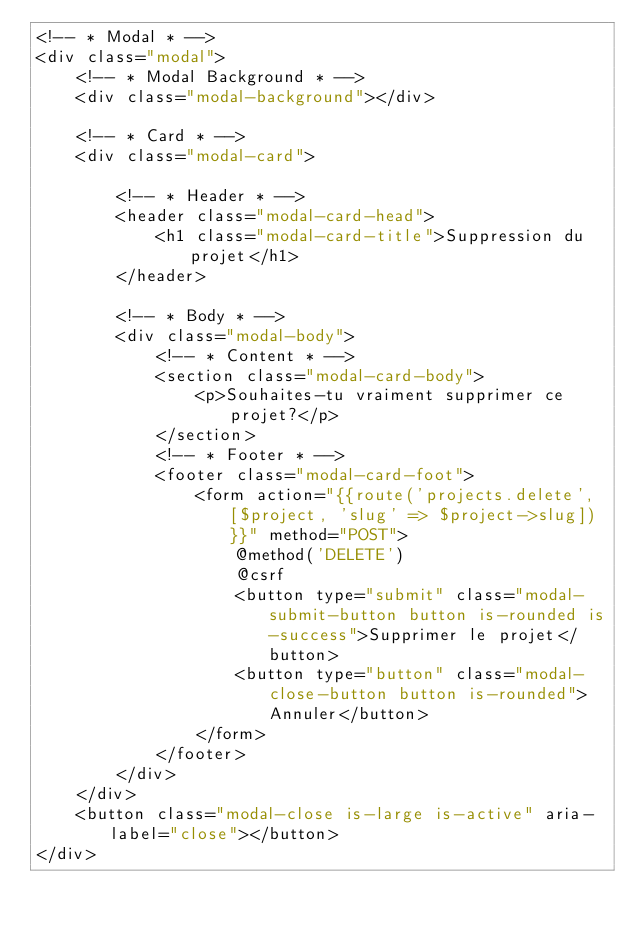Convert code to text. <code><loc_0><loc_0><loc_500><loc_500><_PHP_><!-- * Modal * -->
<div class="modal">
    <!-- * Modal Background * -->
    <div class="modal-background"></div>

    <!-- * Card * -->
    <div class="modal-card">

        <!-- * Header * -->
        <header class="modal-card-head">
            <h1 class="modal-card-title">Suppression du projet</h1>
        </header>

        <!-- * Body * -->
        <div class="modal-body">
            <!-- * Content * -->
            <section class="modal-card-body">
                <p>Souhaites-tu vraiment supprimer ce projet?</p>
            </section>
            <!-- * Footer * -->
            <footer class="modal-card-foot">
                <form action="{{route('projects.delete', [$project, 'slug' => $project->slug])}}" method="POST">
                    @method('DELETE')
                    @csrf
                    <button type="submit" class="modal-submit-button button is-rounded is-success">Supprimer le projet</button>
                    <button type="button" class="modal-close-button button is-rounded">Annuler</button>
                </form>
            </footer>
        </div>
    </div>
    <button class="modal-close is-large is-active" aria-label="close"></button>
</div></code> 